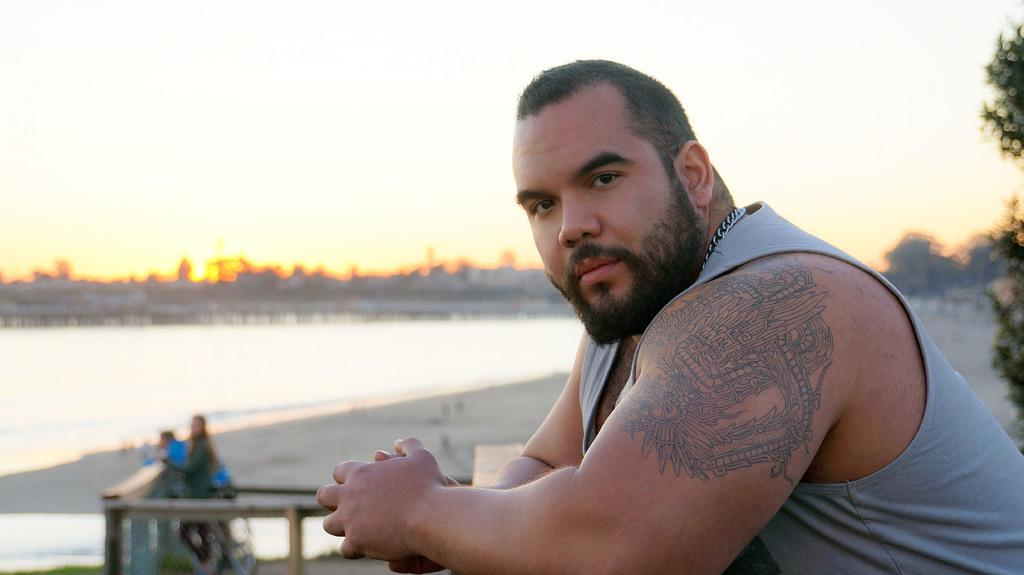Who or what can be seen in the image? There are people in the image. What is the purpose of the fence in the image? The fence is a barrier or boundary in the image. What is the water visible in the image? The water is a body of water, such as a river or lake, in the image. What type of vegetation is present in the image? There are trees in the image. What else can be seen in the image besides people and trees? There are objects in the image. What can be seen in the background of the image? The sky is visible in the background of the image. What type of impulse can be seen affecting the people in the image? There is no indication of any impulse affecting the people in the image. What type of brush is being used by the people in the image? There is no brush visible in the image, and no indication that the people are using any tools or objects. 